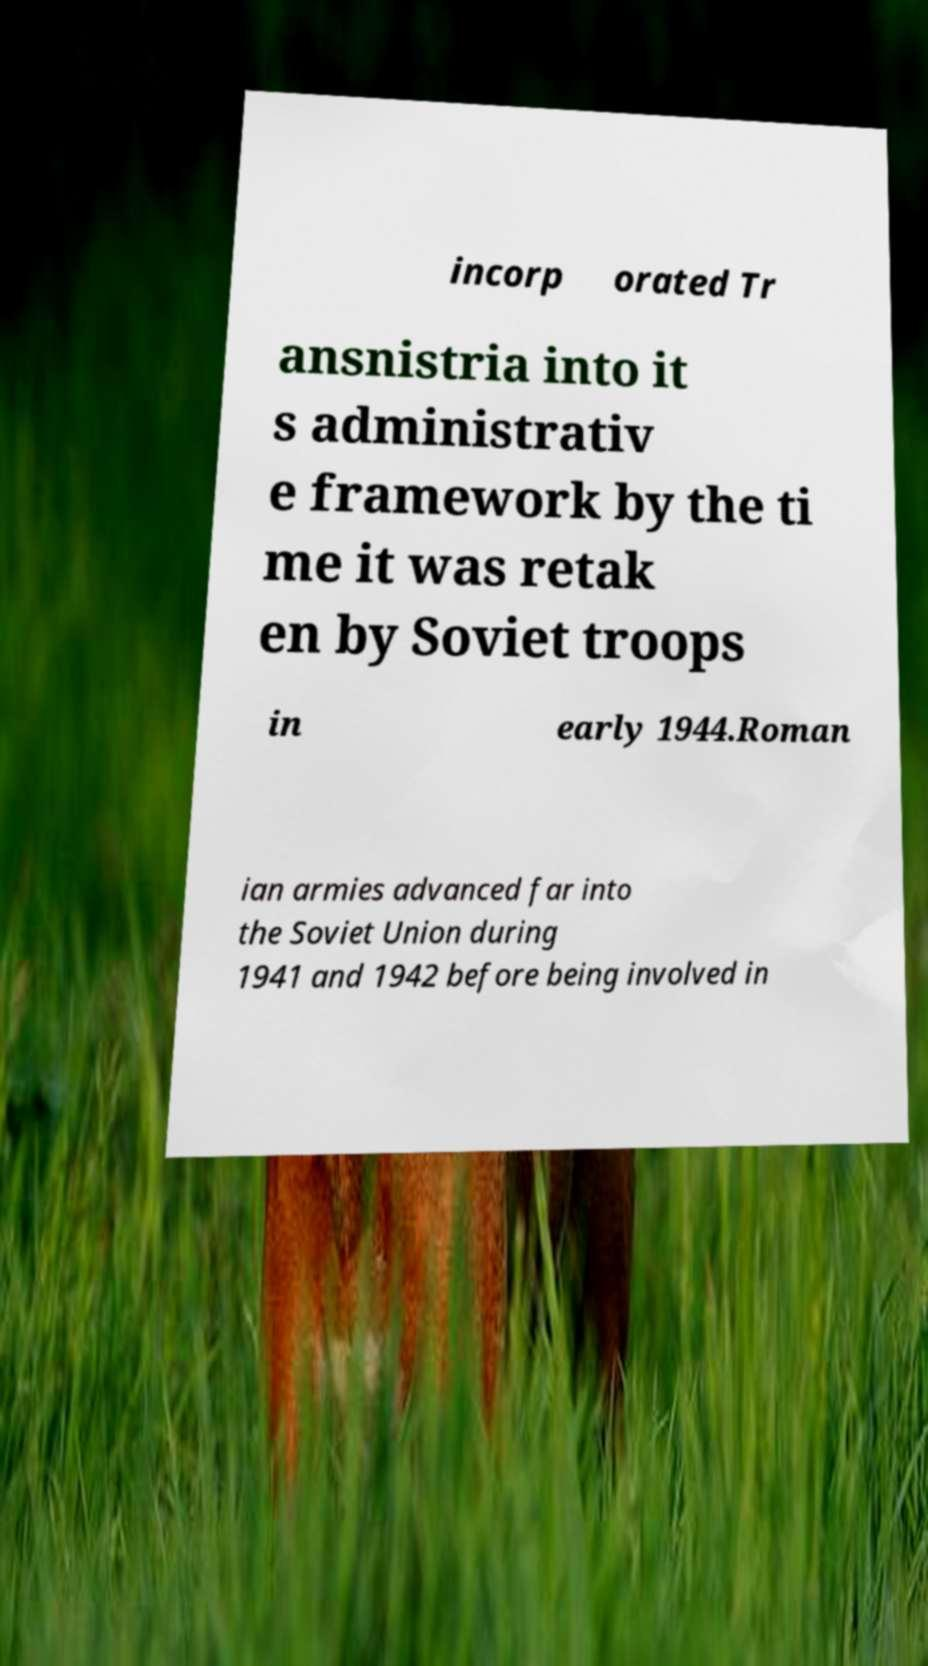For documentation purposes, I need the text within this image transcribed. Could you provide that? incorp orated Tr ansnistria into it s administrativ e framework by the ti me it was retak en by Soviet troops in early 1944.Roman ian armies advanced far into the Soviet Union during 1941 and 1942 before being involved in 